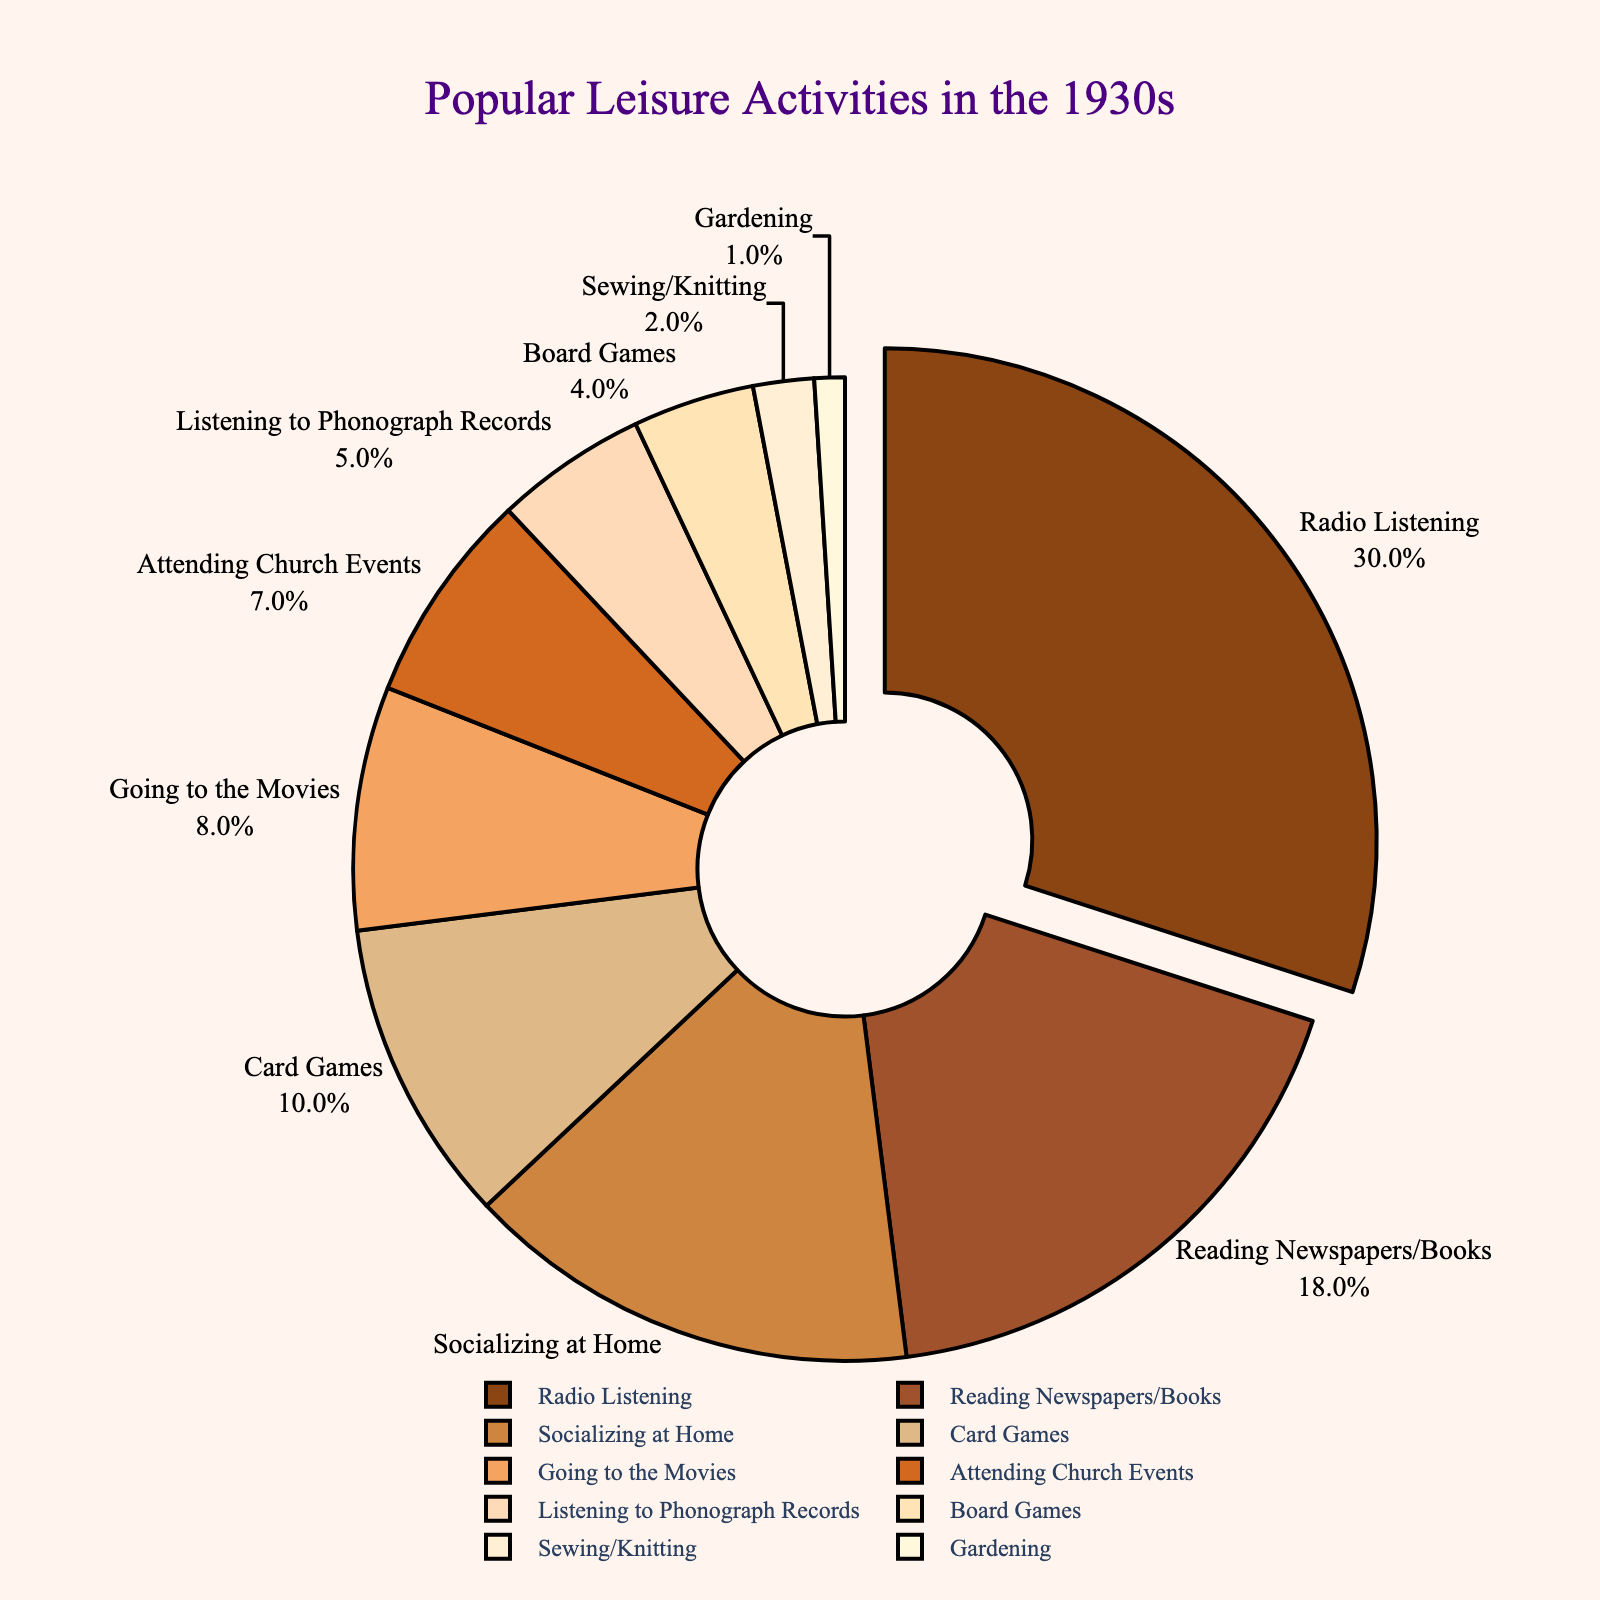Which leisure activity held the largest portion of the chart? The largest portion of the pie chart is visibly distinct as it is pulled out slightly. This segment is labeled "Radio Listening" and occupies 30% of the total activities.
Answer: Radio Listening Which activity held the smallest percentage of leisure time? The smallest segment in the pie chart is the one with the 1% label, which corresponds to "Gardening."
Answer: Gardening What is the total percentage of leisure activities involving games (Card Games and Board Games)? To get the total percentage for games, add the percentages of Card Games and Board Games: 10% + 4% = 14%.
Answer: 14% How does the time spent on Reading Newspapers/Books compare to Attending Church Events? By comparing the segments, Reading Newspapers/Books has a larger portion (18%) than Attending Church Events (7%).
Answer: Reading Newspapers/Books is higher Combine the time spent on Socializing at Home and Sewing/Knitting. What is their combined percentage? To find the combined percentage, sum the percentages of Socializing at Home and Sewing/Knitting: 15% + 2% = 17%.
Answer: 17% Which activity is just under one-third of the total time? The segment labeled "Radio Listening" which accounts for 30%, is just under one-third (33.33%) of the total pie.
Answer: Radio Listening Are there more people listening to phonograph records or playing board games? Comparing the two segments, Listening to Phonograph Records has a larger percentage (5%) than Board Games (4%).
Answer: Listening to Phonograph Records List the activities that individually account for less than 5% of the total. The slices less than 5% are labeled with their percentages: Board Games (4%), Sewing/Knitting (2%), and Gardening (1%).
Answer: Board Games, Sewing/Knitting, Gardening What percentage of time is spent on non-social activities (excluding Socializing at Home and Attending Church Events)? Exclude Socializing at Home (15%) and Attending Church Events (7%) from the total (100%): 100% - 15% - 7% = 78%.
Answer: 78% Calculate the difference between the percentages of Radio Listening and Going to the Movies. Subtract the percentage of Going to the Movies (8%) from Radio Listening (30%): 30% - 8% = 22%.
Answer: 22% 